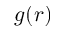Convert formula to latex. <formula><loc_0><loc_0><loc_500><loc_500>g ( r )</formula> 